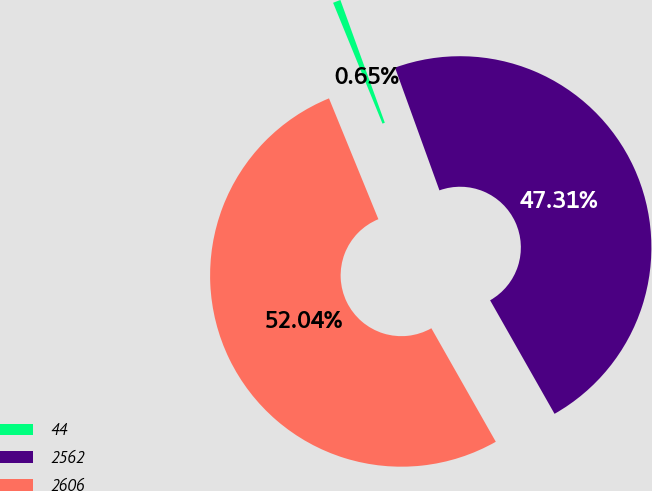Convert chart. <chart><loc_0><loc_0><loc_500><loc_500><pie_chart><fcel>44<fcel>2562<fcel>2606<nl><fcel>0.65%<fcel>47.31%<fcel>52.04%<nl></chart> 